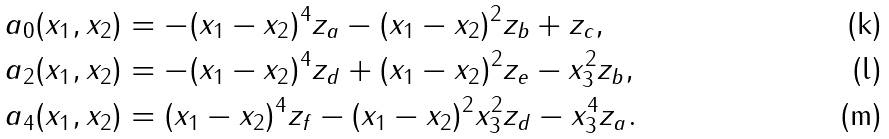<formula> <loc_0><loc_0><loc_500><loc_500>a _ { 0 } ( x _ { 1 } , x _ { 2 } ) & = - ( x _ { 1 } - x _ { 2 } ) ^ { 4 } z _ { a } - ( x _ { 1 } - x _ { 2 } ) ^ { 2 } z _ { b } + z _ { c } , \\ a _ { 2 } ( x _ { 1 } , x _ { 2 } ) & = - ( x _ { 1 } - x _ { 2 } ) ^ { 4 } z _ { d } + ( x _ { 1 } - x _ { 2 } ) ^ { 2 } z _ { e } - x _ { 3 } ^ { 2 } z _ { b } , \\ a _ { 4 } ( x _ { 1 } , x _ { 2 } ) & = ( x _ { 1 } - x _ { 2 } ) ^ { 4 } z _ { f } - ( x _ { 1 } - x _ { 2 } ) ^ { 2 } x _ { 3 } ^ { 2 } z _ { d } - x _ { 3 } ^ { 4 } z _ { a } .</formula> 